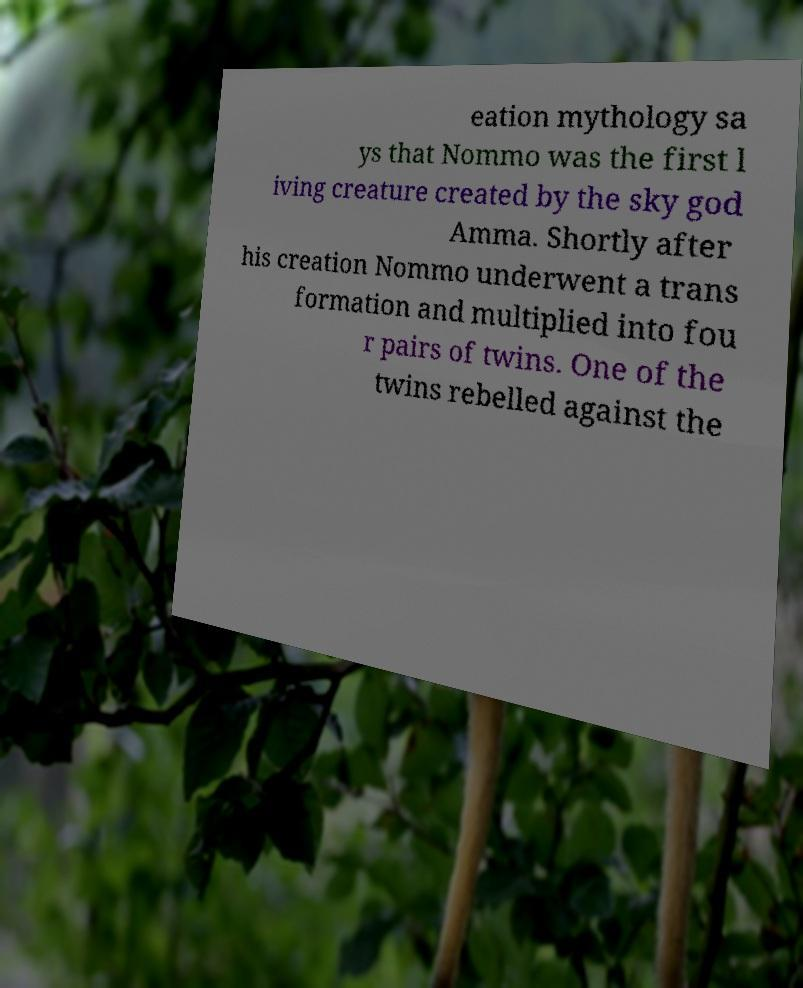Please read and relay the text visible in this image. What does it say? eation mythology sa ys that Nommo was the first l iving creature created by the sky god Amma. Shortly after his creation Nommo underwent a trans formation and multiplied into fou r pairs of twins. One of the twins rebelled against the 